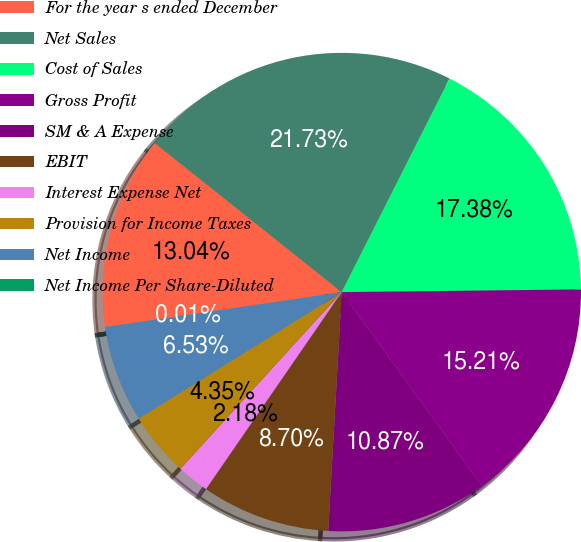Convert chart. <chart><loc_0><loc_0><loc_500><loc_500><pie_chart><fcel>For the year s ended December<fcel>Net Sales<fcel>Cost of Sales<fcel>Gross Profit<fcel>SM & A Expense<fcel>EBIT<fcel>Interest Expense Net<fcel>Provision for Income Taxes<fcel>Net Income<fcel>Net Income Per Share-Diluted<nl><fcel>13.04%<fcel>21.73%<fcel>17.38%<fcel>15.21%<fcel>10.87%<fcel>8.7%<fcel>2.18%<fcel>4.35%<fcel>6.53%<fcel>0.01%<nl></chart> 